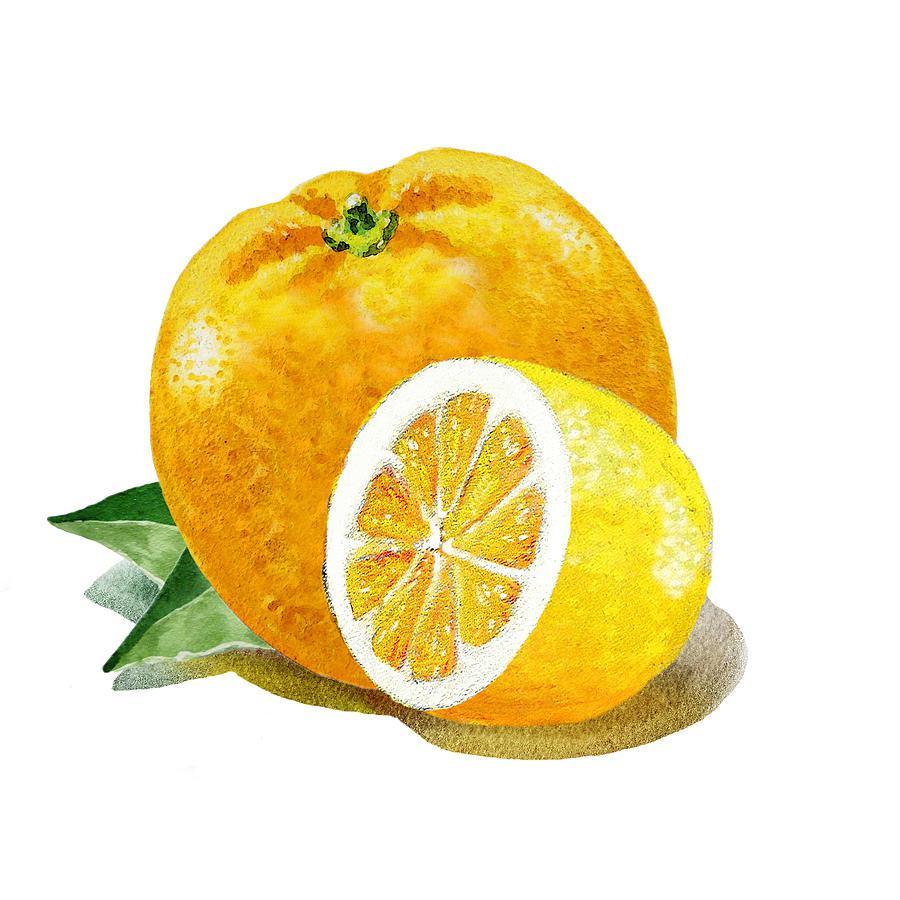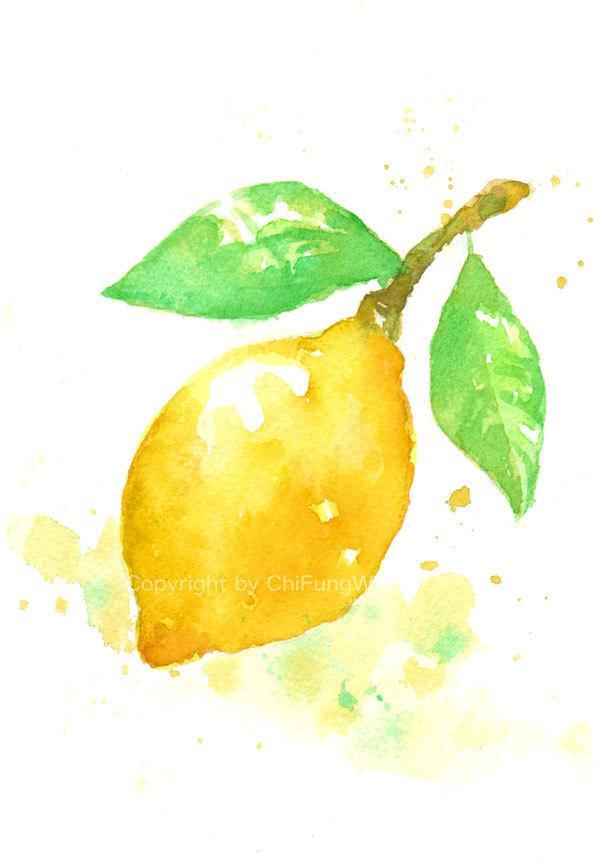The first image is the image on the left, the second image is the image on the right. Given the left and right images, does the statement "Each image includes a whole yellow fruit and a green leaf, one image includes a half-section of fruit, and no image shows unpicked fruit growing on a branch." hold true? Answer yes or no. Yes. The first image is the image on the left, the second image is the image on the right. Assess this claim about the two images: "A stem and leaves are attached to a single lemon, while in a second image a lemon segment is beside one or more whole lemons.". Correct or not? Answer yes or no. Yes. 